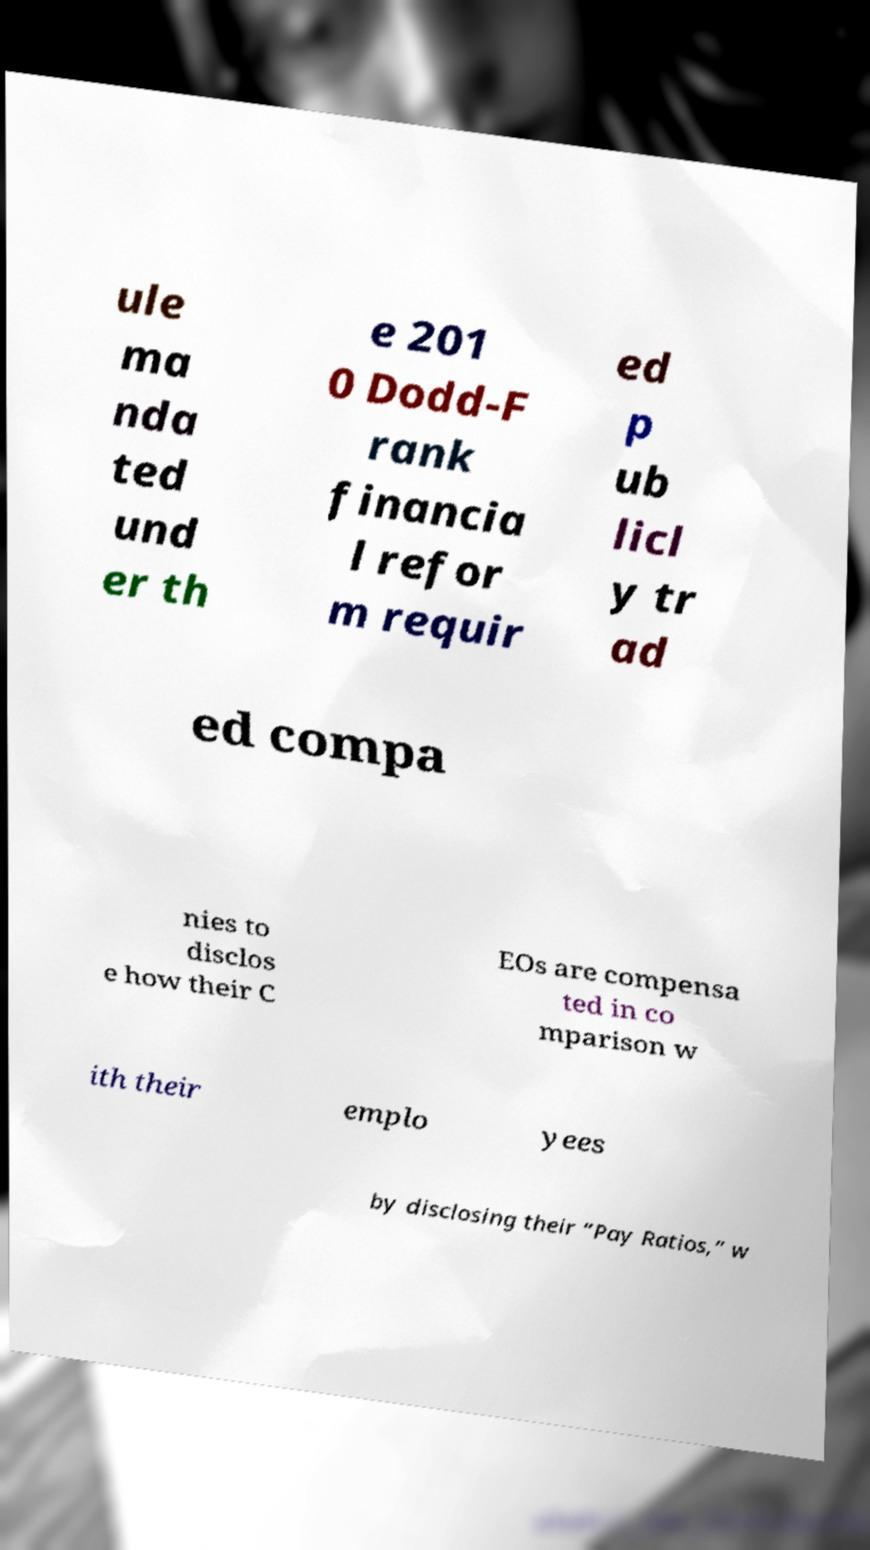Please identify and transcribe the text found in this image. ule ma nda ted und er th e 201 0 Dodd-F rank financia l refor m requir ed p ub licl y tr ad ed compa nies to disclos e how their C EOs are compensa ted in co mparison w ith their emplo yees by disclosing their “Pay Ratios,” w 